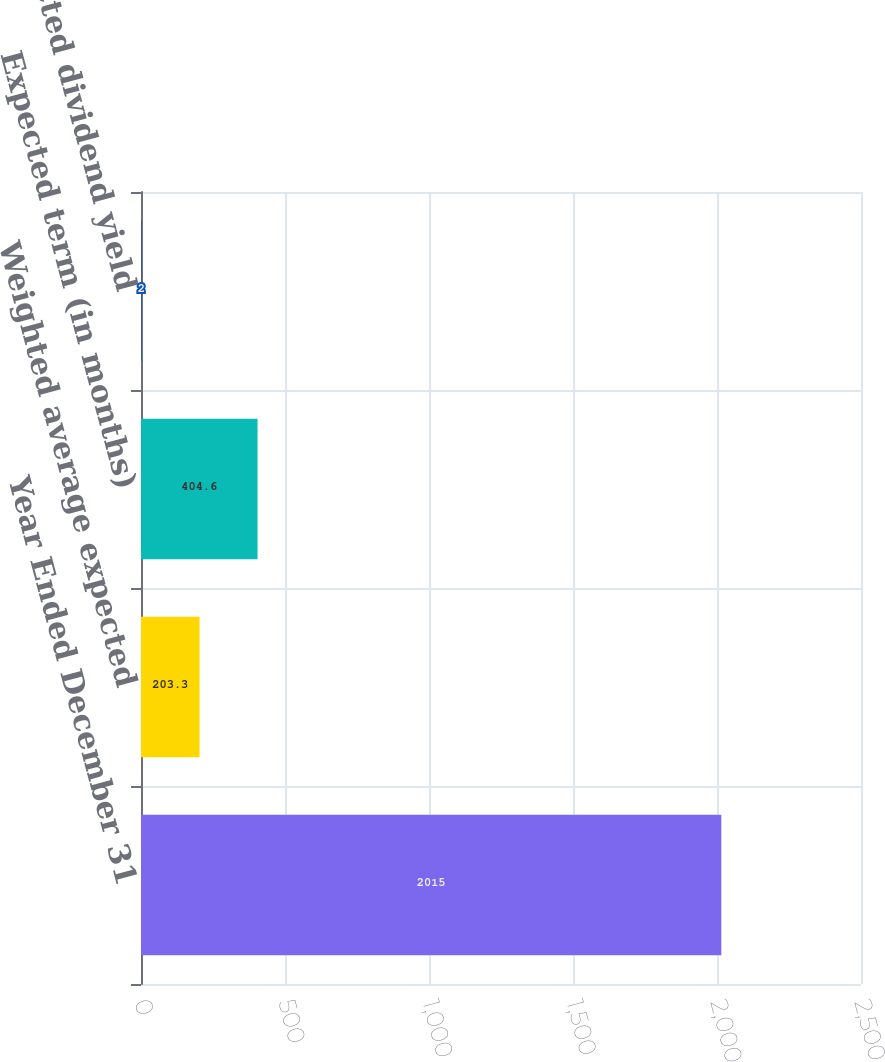Convert chart. <chart><loc_0><loc_0><loc_500><loc_500><bar_chart><fcel>Year Ended December 31<fcel>Weighted average expected<fcel>Expected term (in months)<fcel>Expected dividend yield<nl><fcel>2015<fcel>203.3<fcel>404.6<fcel>2<nl></chart> 